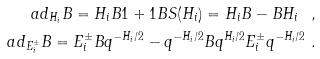Convert formula to latex. <formula><loc_0><loc_0><loc_500><loc_500>a d _ { H _ { i } } B = H _ { i } B 1 + 1 B S ( H _ { i } ) = H _ { i } B - B H _ { i } \ , \\ a d _ { E _ { i } ^ { \pm } } B = E _ { i } ^ { \pm } B q ^ { - H _ { i } / 2 } - q ^ { - H _ { i } / 2 } B q ^ { H _ { i } / 2 } E _ { i } ^ { \pm } q ^ { - H _ { i } / 2 } \ .</formula> 